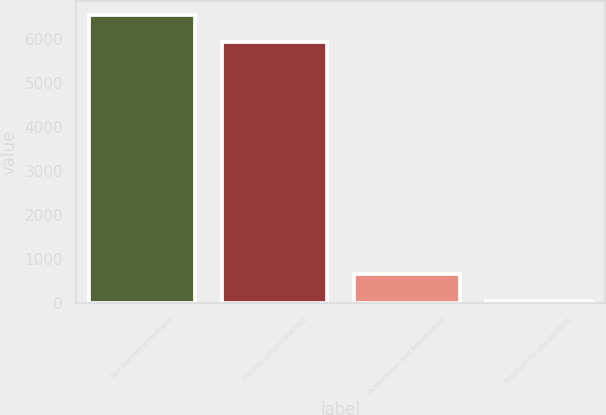<chart> <loc_0><loc_0><loc_500><loc_500><bar_chart><fcel>Net operating revenues<fcel>Dialysis centers and labs<fcel>Depreciation and amortization<fcel>Provision for uncollectible<nl><fcel>6533.8<fcel>5922<fcel>652.8<fcel>41<nl></chart> 